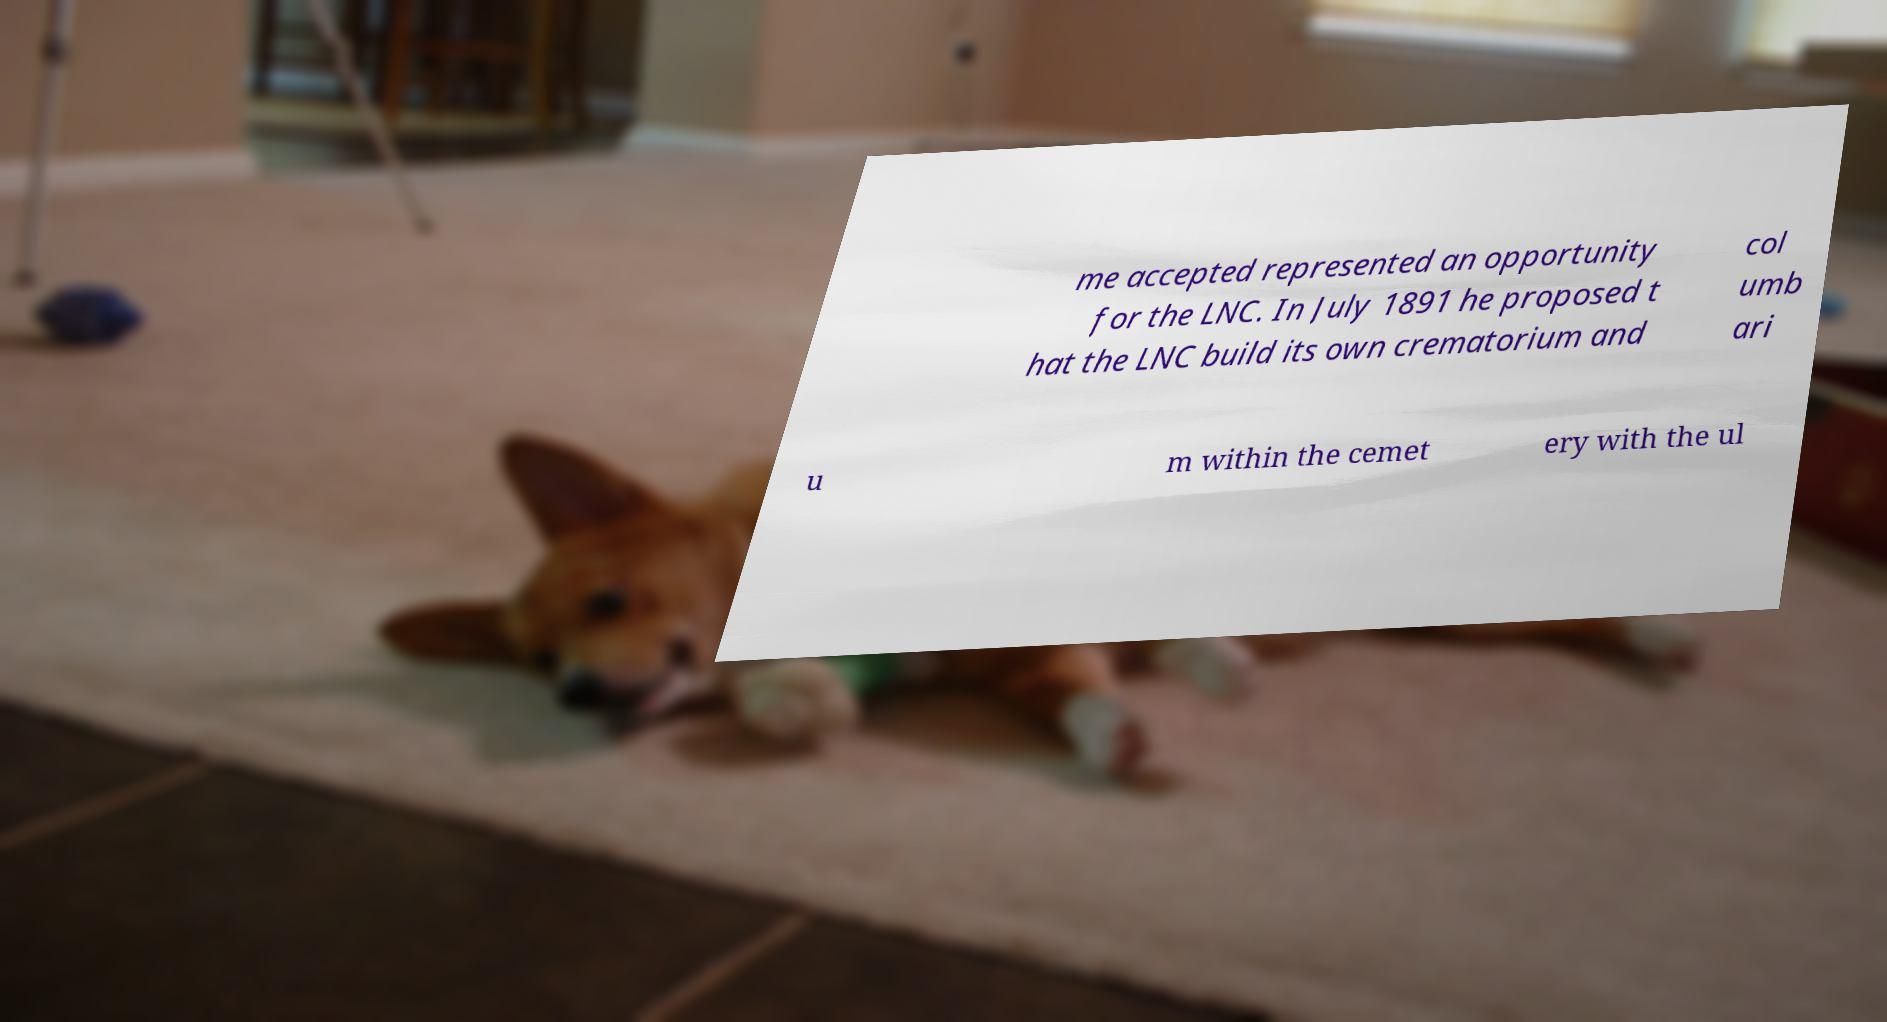Could you extract and type out the text from this image? me accepted represented an opportunity for the LNC. In July 1891 he proposed t hat the LNC build its own crematorium and col umb ari u m within the cemet ery with the ul 